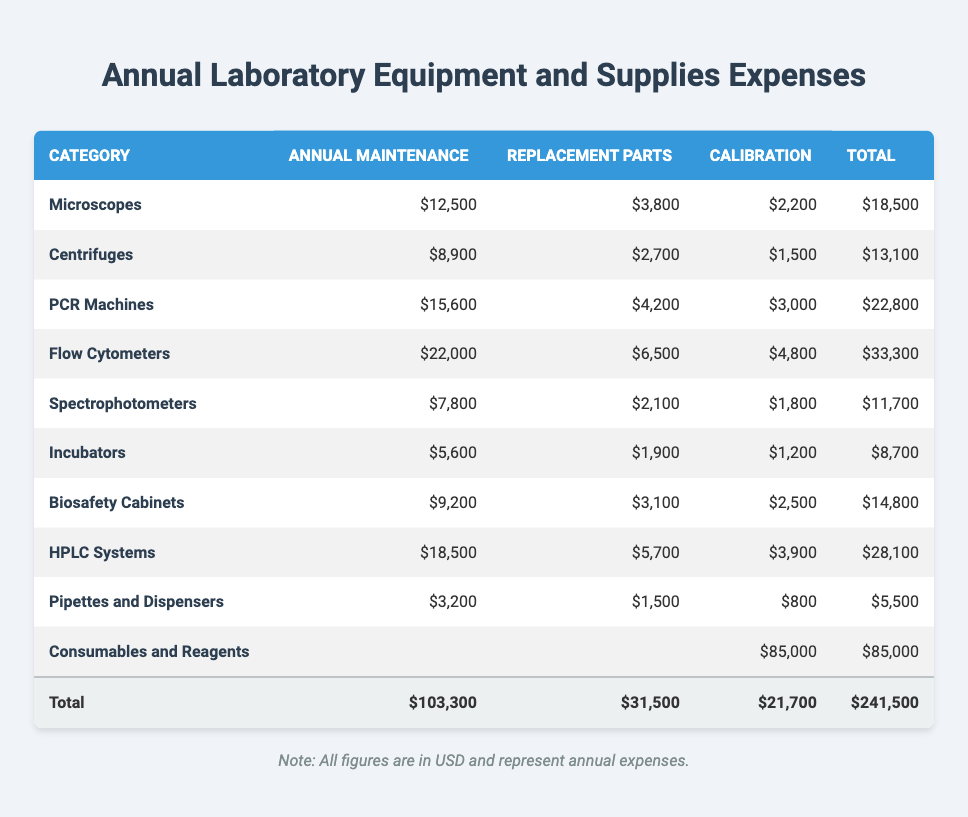What's the total annual maintenance cost for PCR Machines? The annual maintenance cost for PCR Machines is listed directly in the table as $15,600.
Answer: 15,600 Which category has the highest total expense? By examining the total expenses, Flow Cytometers have the highest total cost at $33,300, compared to other categories.
Answer: Flow Cytometers What is the total cost for annual maintenance across all categories? Adding all the annual maintenance costs together: 12,500 + 8,900 + 15,600 + 22,000 + 7,800 + 5,600 + 9,200 + 18,500 + 3,200 + 0 (for Consumables and Reagents) = 103,300.
Answer: 103,300 Do Incubators have a higher annual maintenance cost than Pipettes and Dispensers? The annual maintenance cost for Incubators is $5,600, and for Pipettes and Dispensers it is $3,200. Since $5,600 is greater than $3,200, the statement is true.
Answer: Yes What is the average cost of Replacement Parts for all equipment except for Consumables and Reagents? The total replacement parts cost for all categories except for Consumables and Reagents is 3,800 + 2,700 + 4,200 + 6,500 + 2,100 + 1,900 + 3,100 + 5,700 + 1,500 = 31,600. There are 9 categories, so the average is 31,600 / 9 = 3,511.11 (approx. 3,511).
Answer: 3,511 What percentage of the total expenses is spent on Consumables and Reagents? The total expenses amount to $241,500, and the cost for Consumables and Reagents is $85,000. To find the percentage, use the formula (85,000 / 241,500) * 100, which equals approximately 35.22%.
Answer: 35.22% Which equipment category has the lowest annual maintenance cost? The category with the lowest annual maintenance cost is Pipettes and Dispensers with $3,200, making it the least expensive in this specific category.
Answer: Pipettes and Dispensers Is the total cost for Calibration across all equipment more than $20,000? By adding the calibration costs: 2,200 + 1,500 + 3,000 + 4,800 + 1,800 + 1,200 + 2,500 + 3,900 + 800 = 21,700, which exceeds $20,000. Hence, the statement is true.
Answer: Yes What is the total expense for calibration for Flow Cytometers? The calibration cost for Flow Cytometers is explicitly stated in the table as $4,800.
Answer: 4,800 